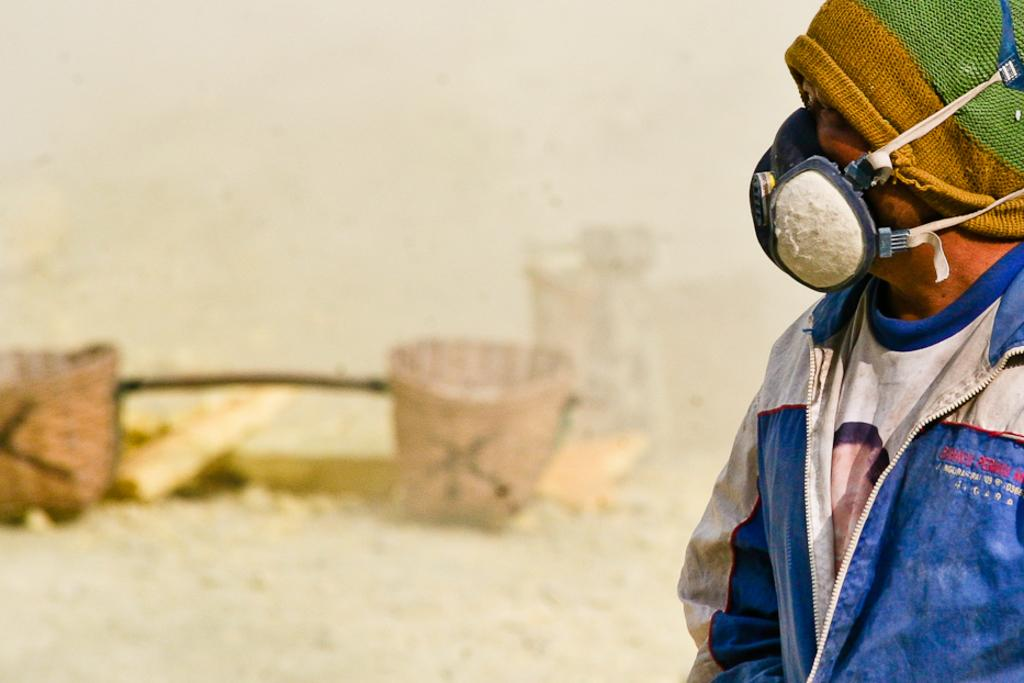What is the main subject in the foreground of the picture? There is a man in the foreground of the picture. What is the man wearing on his upper body? The man is wearing a blue coat. What is the man wearing on his face? The man is wearing a mask. What is the man wearing on his head? The man has a cap on his head. What can be seen on the ground in the background of the image? There are baskets on the ground in the background of the image. What type of tin can be seen in the man's hand in the image? There is no tin visible in the man's hand in the image. What color are the grapes that the man is holding in the image? There are no grapes present in the image. 